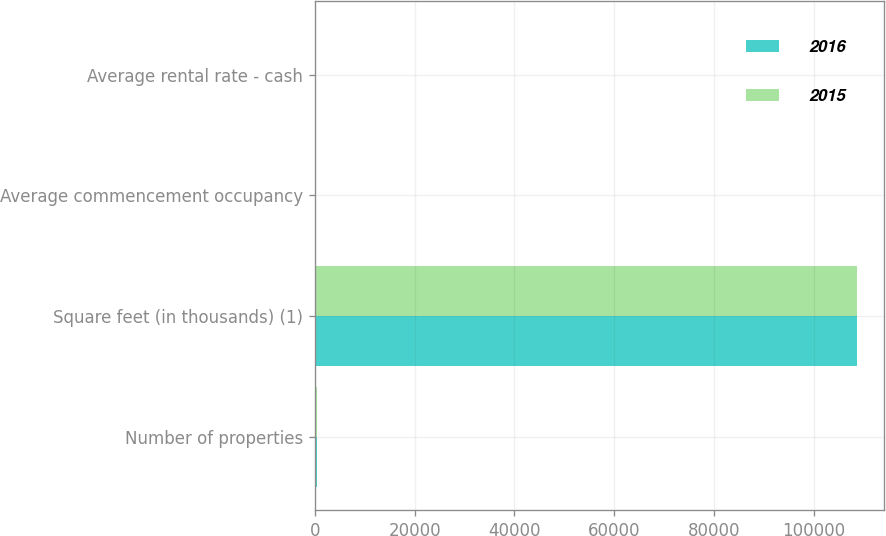Convert chart to OTSL. <chart><loc_0><loc_0><loc_500><loc_500><stacked_bar_chart><ecel><fcel>Number of properties<fcel>Square feet (in thousands) (1)<fcel>Average commencement occupancy<fcel>Average rental rate - cash<nl><fcel>2016<fcel>464<fcel>108604<fcel>98.1<fcel>4.9<nl><fcel>2015<fcel>464<fcel>108604<fcel>97<fcel>4.82<nl></chart> 